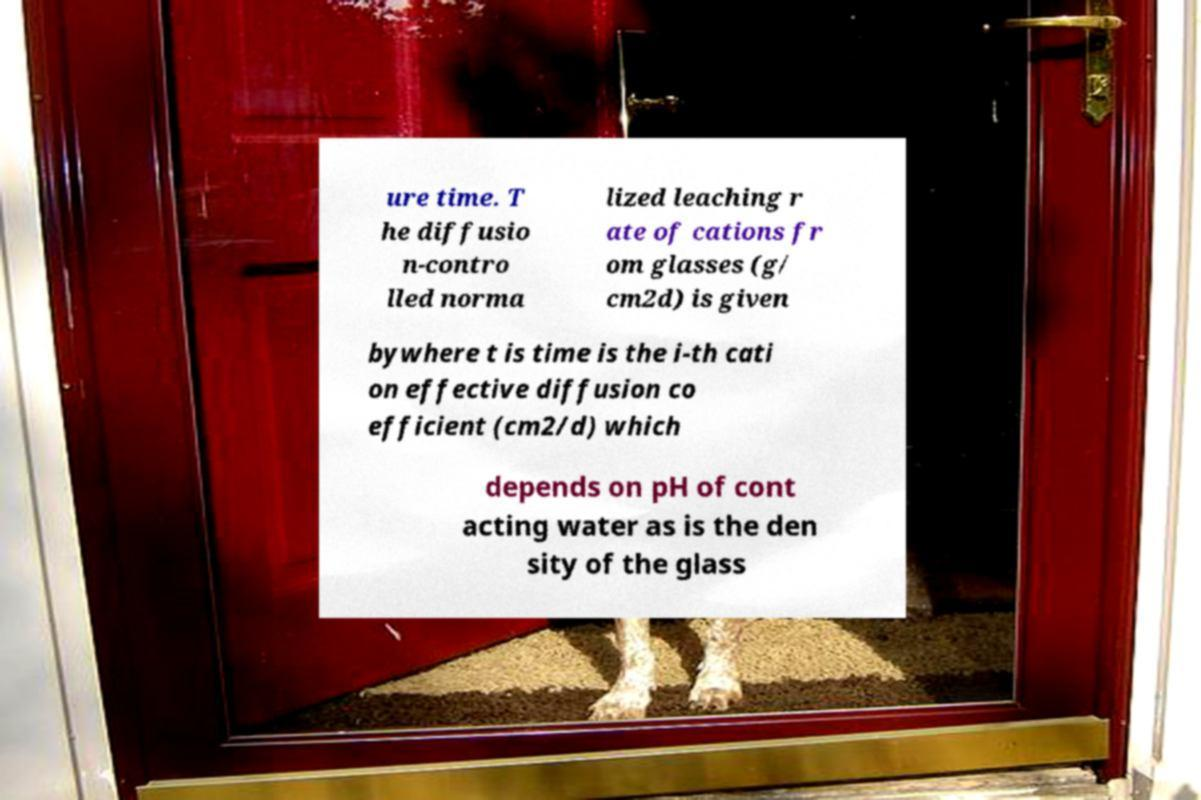Please read and relay the text visible in this image. What does it say? ure time. T he diffusio n-contro lled norma lized leaching r ate of cations fr om glasses (g/ cm2d) is given bywhere t is time is the i-th cati on effective diffusion co efficient (cm2/d) which depends on pH of cont acting water as is the den sity of the glass 